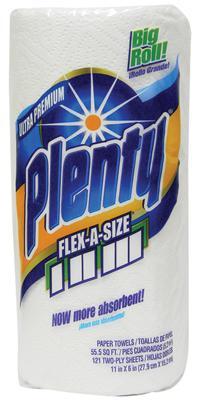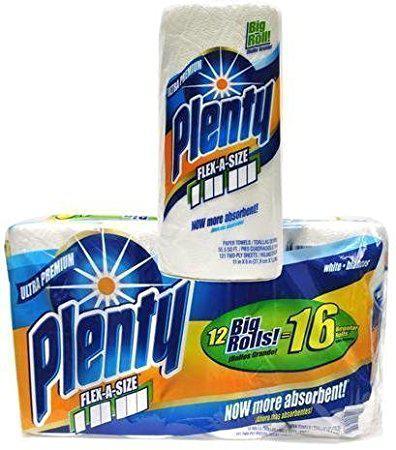The first image is the image on the left, the second image is the image on the right. Given the left and right images, does the statement "There are exactly 31 rolls of paper towels." hold true? Answer yes or no. No. 